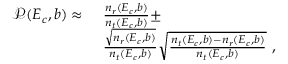<formula> <loc_0><loc_0><loc_500><loc_500>\begin{array} { r l } { \mathcal { P } ( E _ { c } , b ) \approx } & { \frac { n _ { r } ( E _ { c } , b ) } { n _ { t } ( E _ { c } , b ) } \pm } \\ & { \frac { \sqrt { n _ { r } ( E _ { c } , b ) } } { n _ { t } ( E _ { c } , b ) } \sqrt { \frac { n _ { t } ( E _ { c } , b ) - n _ { r } ( E _ { c } , b ) } { n _ { t } ( E _ { c } , b ) } } , } \end{array}</formula> 